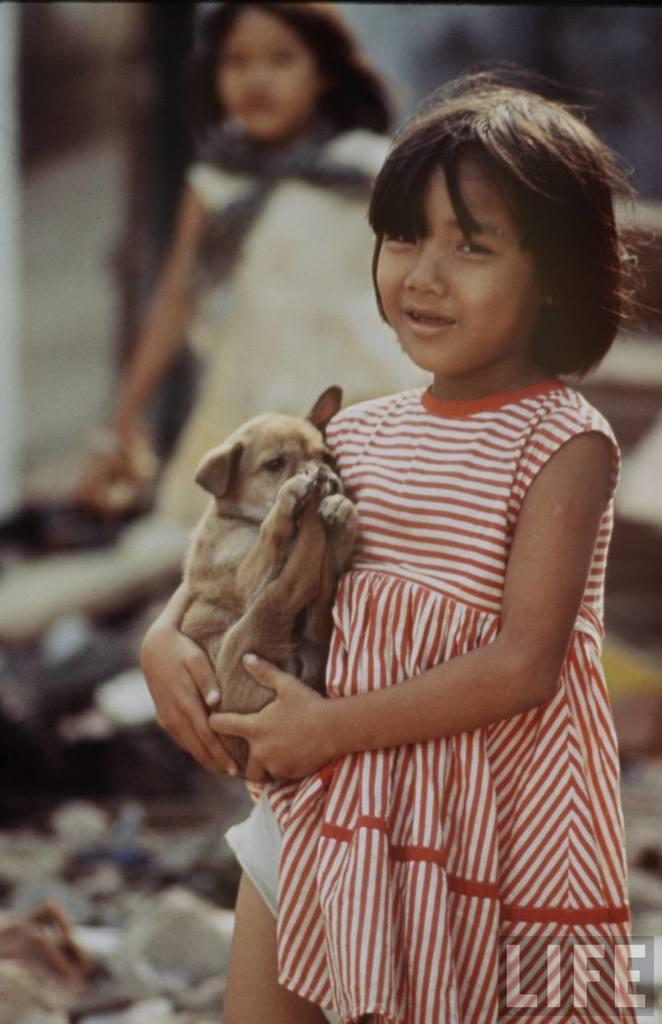Who is the main subject in the image? There is a baby girl in the image. What is the baby girl holding? The baby girl is holding a dog. Can you describe the woman in the background? There is a woman in the background of the image, and she is staring at the baby girl. What type of fireman is present in the image? There is no fireman present in the image. Is the baby girl sleeping in a crib in the image? No, the baby girl is not sleeping in a crib in the image; she is holding a dog. 